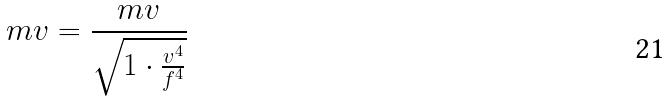<formula> <loc_0><loc_0><loc_500><loc_500>m v = \frac { m v } { \sqrt { 1 \cdot \frac { v ^ { 4 } } { f ^ { 4 } } } }</formula> 